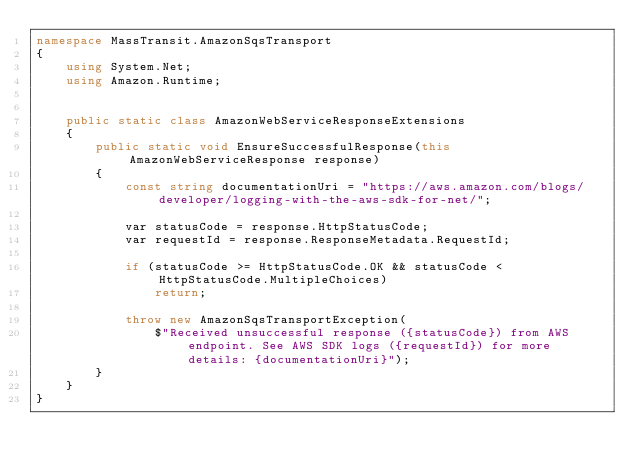<code> <loc_0><loc_0><loc_500><loc_500><_C#_>namespace MassTransit.AmazonSqsTransport
{
    using System.Net;
    using Amazon.Runtime;


    public static class AmazonWebServiceResponseExtensions
    {
        public static void EnsureSuccessfulResponse(this AmazonWebServiceResponse response)
        {
            const string documentationUri = "https://aws.amazon.com/blogs/developer/logging-with-the-aws-sdk-for-net/";

            var statusCode = response.HttpStatusCode;
            var requestId = response.ResponseMetadata.RequestId;

            if (statusCode >= HttpStatusCode.OK && statusCode < HttpStatusCode.MultipleChoices)
                return;

            throw new AmazonSqsTransportException(
                $"Received unsuccessful response ({statusCode}) from AWS endpoint. See AWS SDK logs ({requestId}) for more details: {documentationUri}");
        }
    }
}
</code> 